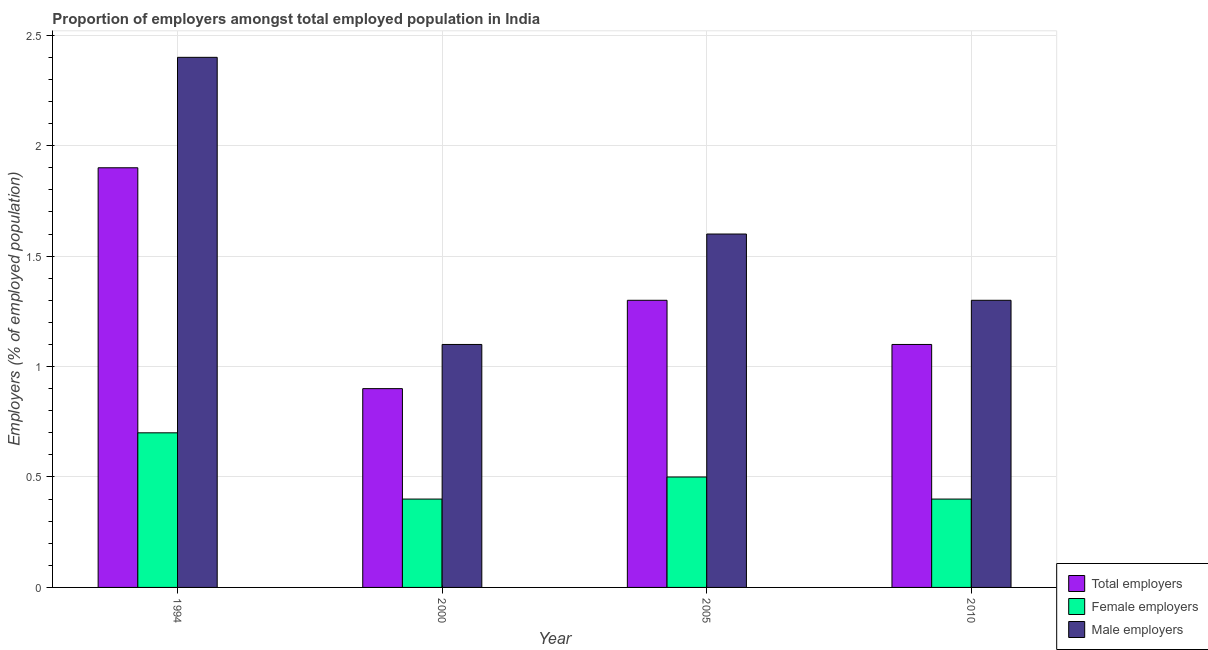How many bars are there on the 1st tick from the right?
Provide a succinct answer. 3. What is the label of the 1st group of bars from the left?
Provide a short and direct response. 1994. What is the percentage of female employers in 1994?
Offer a terse response. 0.7. Across all years, what is the maximum percentage of female employers?
Provide a short and direct response. 0.7. Across all years, what is the minimum percentage of total employers?
Provide a short and direct response. 0.9. In which year was the percentage of male employers maximum?
Give a very brief answer. 1994. What is the total percentage of total employers in the graph?
Your response must be concise. 5.2. What is the difference between the percentage of total employers in 2005 and that in 2010?
Your response must be concise. 0.2. What is the difference between the percentage of total employers in 2000 and the percentage of female employers in 2005?
Your answer should be compact. -0.4. What is the average percentage of male employers per year?
Your response must be concise. 1.6. What is the ratio of the percentage of male employers in 2000 to that in 2005?
Make the answer very short. 0.69. Is the difference between the percentage of total employers in 1994 and 2000 greater than the difference between the percentage of female employers in 1994 and 2000?
Provide a succinct answer. No. What is the difference between the highest and the second highest percentage of male employers?
Your answer should be compact. 0.8. What is the difference between the highest and the lowest percentage of total employers?
Keep it short and to the point. 1. What does the 2nd bar from the left in 1994 represents?
Ensure brevity in your answer.  Female employers. What does the 2nd bar from the right in 2005 represents?
Your answer should be compact. Female employers. How many bars are there?
Provide a succinct answer. 12. How many years are there in the graph?
Keep it short and to the point. 4. Are the values on the major ticks of Y-axis written in scientific E-notation?
Your answer should be very brief. No. Does the graph contain any zero values?
Your answer should be compact. No. Does the graph contain grids?
Provide a succinct answer. Yes. Where does the legend appear in the graph?
Make the answer very short. Bottom right. How many legend labels are there?
Keep it short and to the point. 3. What is the title of the graph?
Offer a very short reply. Proportion of employers amongst total employed population in India. Does "Secondary" appear as one of the legend labels in the graph?
Offer a very short reply. No. What is the label or title of the Y-axis?
Give a very brief answer. Employers (% of employed population). What is the Employers (% of employed population) in Total employers in 1994?
Offer a very short reply. 1.9. What is the Employers (% of employed population) in Female employers in 1994?
Give a very brief answer. 0.7. What is the Employers (% of employed population) in Male employers in 1994?
Provide a succinct answer. 2.4. What is the Employers (% of employed population) of Total employers in 2000?
Keep it short and to the point. 0.9. What is the Employers (% of employed population) of Female employers in 2000?
Give a very brief answer. 0.4. What is the Employers (% of employed population) in Male employers in 2000?
Give a very brief answer. 1.1. What is the Employers (% of employed population) in Total employers in 2005?
Ensure brevity in your answer.  1.3. What is the Employers (% of employed population) in Male employers in 2005?
Offer a terse response. 1.6. What is the Employers (% of employed population) in Total employers in 2010?
Provide a succinct answer. 1.1. What is the Employers (% of employed population) of Female employers in 2010?
Your answer should be very brief. 0.4. What is the Employers (% of employed population) in Male employers in 2010?
Your answer should be very brief. 1.3. Across all years, what is the maximum Employers (% of employed population) in Total employers?
Provide a short and direct response. 1.9. Across all years, what is the maximum Employers (% of employed population) of Female employers?
Ensure brevity in your answer.  0.7. Across all years, what is the maximum Employers (% of employed population) of Male employers?
Make the answer very short. 2.4. Across all years, what is the minimum Employers (% of employed population) in Total employers?
Offer a terse response. 0.9. Across all years, what is the minimum Employers (% of employed population) of Female employers?
Offer a terse response. 0.4. Across all years, what is the minimum Employers (% of employed population) of Male employers?
Your answer should be compact. 1.1. What is the total Employers (% of employed population) in Male employers in the graph?
Ensure brevity in your answer.  6.4. What is the difference between the Employers (% of employed population) in Total employers in 1994 and that in 2000?
Provide a succinct answer. 1. What is the difference between the Employers (% of employed population) of Male employers in 1994 and that in 2000?
Provide a short and direct response. 1.3. What is the difference between the Employers (% of employed population) in Male employers in 1994 and that in 2005?
Provide a short and direct response. 0.8. What is the difference between the Employers (% of employed population) in Male employers in 1994 and that in 2010?
Give a very brief answer. 1.1. What is the difference between the Employers (% of employed population) of Female employers in 2000 and that in 2005?
Provide a succinct answer. -0.1. What is the difference between the Employers (% of employed population) in Total employers in 2000 and that in 2010?
Provide a succinct answer. -0.2. What is the difference between the Employers (% of employed population) in Female employers in 2000 and that in 2010?
Your answer should be compact. 0. What is the difference between the Employers (% of employed population) in Male employers in 2000 and that in 2010?
Your answer should be very brief. -0.2. What is the difference between the Employers (% of employed population) in Total employers in 2005 and that in 2010?
Provide a succinct answer. 0.2. What is the difference between the Employers (% of employed population) of Male employers in 2005 and that in 2010?
Keep it short and to the point. 0.3. What is the difference between the Employers (% of employed population) in Total employers in 1994 and the Employers (% of employed population) in Female employers in 2000?
Make the answer very short. 1.5. What is the difference between the Employers (% of employed population) of Total employers in 1994 and the Employers (% of employed population) of Male employers in 2000?
Give a very brief answer. 0.8. What is the difference between the Employers (% of employed population) in Female employers in 1994 and the Employers (% of employed population) in Male employers in 2005?
Your answer should be very brief. -0.9. What is the difference between the Employers (% of employed population) of Total employers in 1994 and the Employers (% of employed population) of Female employers in 2010?
Your answer should be compact. 1.5. What is the difference between the Employers (% of employed population) of Total employers in 1994 and the Employers (% of employed population) of Male employers in 2010?
Your answer should be compact. 0.6. What is the difference between the Employers (% of employed population) of Total employers in 2000 and the Employers (% of employed population) of Female employers in 2005?
Your answer should be very brief. 0.4. What is the difference between the Employers (% of employed population) of Total employers in 2000 and the Employers (% of employed population) of Male employers in 2005?
Make the answer very short. -0.7. What is the difference between the Employers (% of employed population) in Total employers in 2000 and the Employers (% of employed population) in Female employers in 2010?
Make the answer very short. 0.5. What is the difference between the Employers (% of employed population) in Total employers in 2000 and the Employers (% of employed population) in Male employers in 2010?
Your response must be concise. -0.4. What is the difference between the Employers (% of employed population) of Total employers in 2005 and the Employers (% of employed population) of Female employers in 2010?
Offer a very short reply. 0.9. What is the difference between the Employers (% of employed population) of Female employers in 2005 and the Employers (% of employed population) of Male employers in 2010?
Your answer should be very brief. -0.8. What is the average Employers (% of employed population) of Female employers per year?
Your answer should be compact. 0.5. What is the average Employers (% of employed population) in Male employers per year?
Offer a terse response. 1.6. In the year 1994, what is the difference between the Employers (% of employed population) in Total employers and Employers (% of employed population) in Female employers?
Provide a short and direct response. 1.2. In the year 1994, what is the difference between the Employers (% of employed population) in Total employers and Employers (% of employed population) in Male employers?
Your answer should be compact. -0.5. In the year 2000, what is the difference between the Employers (% of employed population) in Total employers and Employers (% of employed population) in Female employers?
Your answer should be compact. 0.5. In the year 2005, what is the difference between the Employers (% of employed population) in Total employers and Employers (% of employed population) in Male employers?
Give a very brief answer. -0.3. In the year 2005, what is the difference between the Employers (% of employed population) in Female employers and Employers (% of employed population) in Male employers?
Give a very brief answer. -1.1. In the year 2010, what is the difference between the Employers (% of employed population) of Total employers and Employers (% of employed population) of Female employers?
Offer a very short reply. 0.7. In the year 2010, what is the difference between the Employers (% of employed population) of Female employers and Employers (% of employed population) of Male employers?
Offer a terse response. -0.9. What is the ratio of the Employers (% of employed population) in Total employers in 1994 to that in 2000?
Your answer should be very brief. 2.11. What is the ratio of the Employers (% of employed population) in Female employers in 1994 to that in 2000?
Ensure brevity in your answer.  1.75. What is the ratio of the Employers (% of employed population) in Male employers in 1994 to that in 2000?
Keep it short and to the point. 2.18. What is the ratio of the Employers (% of employed population) of Total employers in 1994 to that in 2005?
Your response must be concise. 1.46. What is the ratio of the Employers (% of employed population) of Female employers in 1994 to that in 2005?
Provide a short and direct response. 1.4. What is the ratio of the Employers (% of employed population) in Total employers in 1994 to that in 2010?
Offer a very short reply. 1.73. What is the ratio of the Employers (% of employed population) of Female employers in 1994 to that in 2010?
Make the answer very short. 1.75. What is the ratio of the Employers (% of employed population) of Male employers in 1994 to that in 2010?
Your answer should be very brief. 1.85. What is the ratio of the Employers (% of employed population) in Total employers in 2000 to that in 2005?
Ensure brevity in your answer.  0.69. What is the ratio of the Employers (% of employed population) of Female employers in 2000 to that in 2005?
Your response must be concise. 0.8. What is the ratio of the Employers (% of employed population) in Male employers in 2000 to that in 2005?
Make the answer very short. 0.69. What is the ratio of the Employers (% of employed population) of Total employers in 2000 to that in 2010?
Your answer should be very brief. 0.82. What is the ratio of the Employers (% of employed population) of Male employers in 2000 to that in 2010?
Provide a succinct answer. 0.85. What is the ratio of the Employers (% of employed population) of Total employers in 2005 to that in 2010?
Your response must be concise. 1.18. What is the ratio of the Employers (% of employed population) in Male employers in 2005 to that in 2010?
Your answer should be very brief. 1.23. What is the difference between the highest and the second highest Employers (% of employed population) of Male employers?
Give a very brief answer. 0.8. 